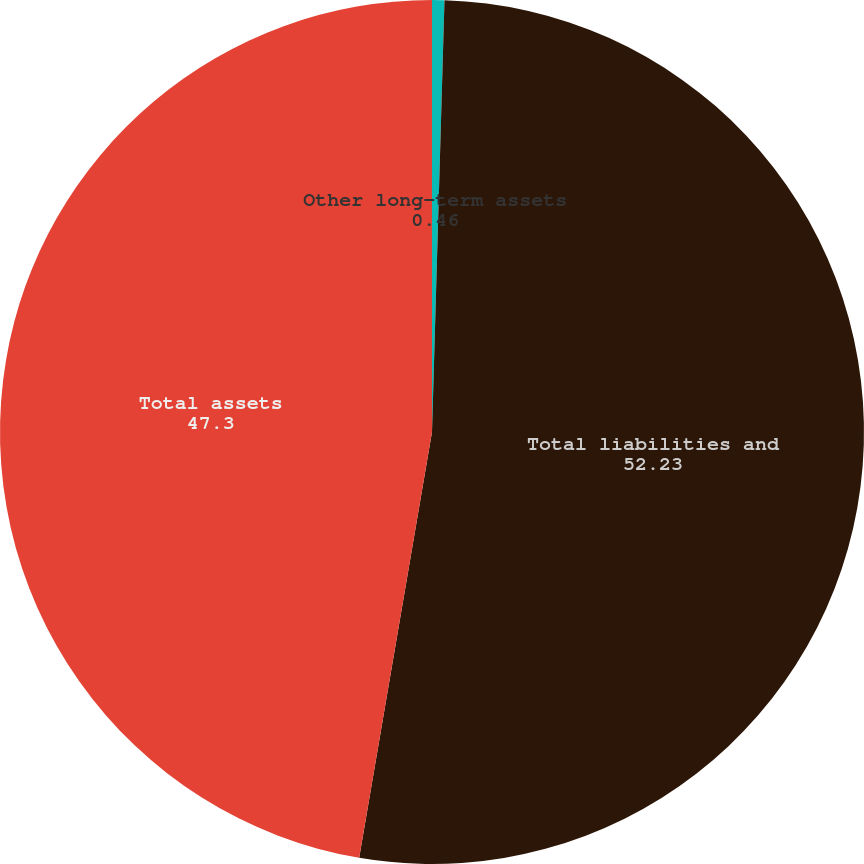Convert chart. <chart><loc_0><loc_0><loc_500><loc_500><pie_chart><fcel>Other long-term assets<fcel>Total liabilities and<fcel>Total assets<nl><fcel>0.46%<fcel>52.23%<fcel>47.3%<nl></chart> 